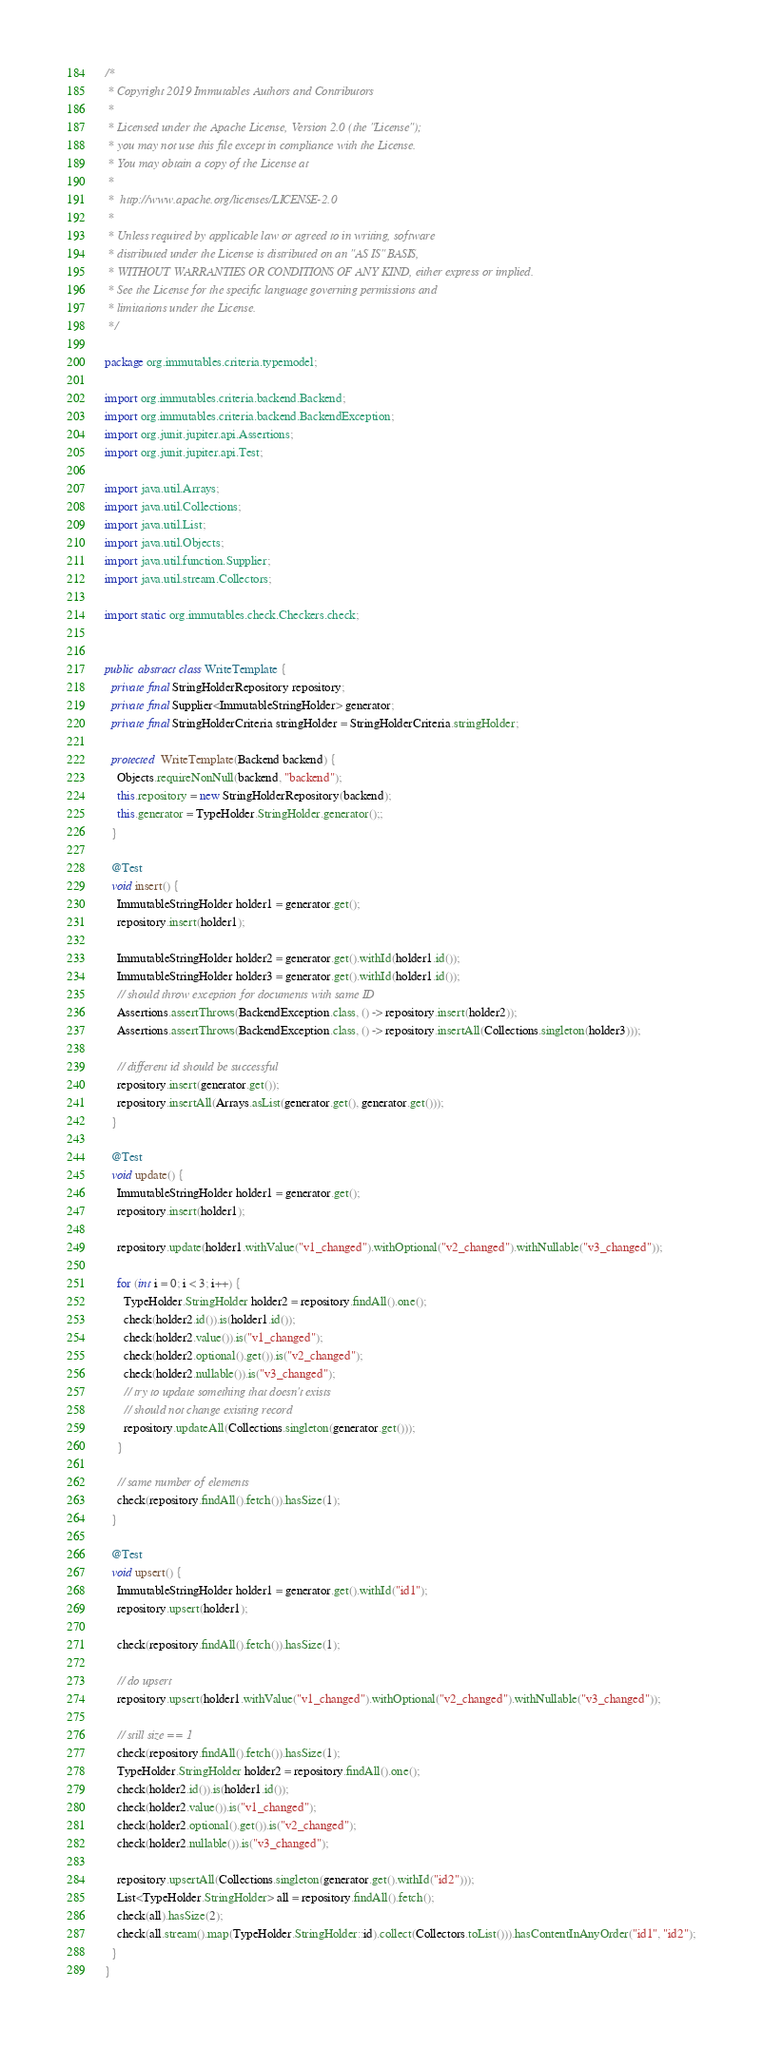Convert code to text. <code><loc_0><loc_0><loc_500><loc_500><_Java_>/*
 * Copyright 2019 Immutables Authors and Contributors
 *
 * Licensed under the Apache License, Version 2.0 (the "License");
 * you may not use this file except in compliance with the License.
 * You may obtain a copy of the License at
 *
 *  http://www.apache.org/licenses/LICENSE-2.0
 *
 * Unless required by applicable law or agreed to in writing, software
 * distributed under the License is distributed on an "AS IS" BASIS,
 * WITHOUT WARRANTIES OR CONDITIONS OF ANY KIND, either express or implied.
 * See the License for the specific language governing permissions and
 * limitations under the License.
 */

package org.immutables.criteria.typemodel;

import org.immutables.criteria.backend.Backend;
import org.immutables.criteria.backend.BackendException;
import org.junit.jupiter.api.Assertions;
import org.junit.jupiter.api.Test;

import java.util.Arrays;
import java.util.Collections;
import java.util.List;
import java.util.Objects;
import java.util.function.Supplier;
import java.util.stream.Collectors;

import static org.immutables.check.Checkers.check;


public abstract class WriteTemplate {
  private final StringHolderRepository repository;
  private final Supplier<ImmutableStringHolder> generator;
  private final StringHolderCriteria stringHolder = StringHolderCriteria.stringHolder;

  protected WriteTemplate(Backend backend) {
    Objects.requireNonNull(backend, "backend");
    this.repository = new StringHolderRepository(backend);
    this.generator = TypeHolder.StringHolder.generator();;
  }

  @Test
  void insert() {
    ImmutableStringHolder holder1 = generator.get();
    repository.insert(holder1);

    ImmutableStringHolder holder2 = generator.get().withId(holder1.id());
    ImmutableStringHolder holder3 = generator.get().withId(holder1.id());
    // should throw exception for documents with same ID
    Assertions.assertThrows(BackendException.class, () -> repository.insert(holder2));
    Assertions.assertThrows(BackendException.class, () -> repository.insertAll(Collections.singleton(holder3)));

    // different id should be successful
    repository.insert(generator.get());
    repository.insertAll(Arrays.asList(generator.get(), generator.get()));
  }

  @Test
  void update() {
    ImmutableStringHolder holder1 = generator.get();
    repository.insert(holder1);

    repository.update(holder1.withValue("v1_changed").withOptional("v2_changed").withNullable("v3_changed"));

    for (int i = 0; i < 3; i++) {
      TypeHolder.StringHolder holder2 = repository.findAll().one();
      check(holder2.id()).is(holder1.id());
      check(holder2.value()).is("v1_changed");
      check(holder2.optional().get()).is("v2_changed");
      check(holder2.nullable()).is("v3_changed");
      // try to update something that doesn't exists
      // should not change existing record
      repository.updateAll(Collections.singleton(generator.get()));
    }

    // same number of elements
    check(repository.findAll().fetch()).hasSize(1);
  }

  @Test
  void upsert() {
    ImmutableStringHolder holder1 = generator.get().withId("id1");
    repository.upsert(holder1);

    check(repository.findAll().fetch()).hasSize(1);

    // do upsert
    repository.upsert(holder1.withValue("v1_changed").withOptional("v2_changed").withNullable("v3_changed"));

    // still size == 1
    check(repository.findAll().fetch()).hasSize(1);
    TypeHolder.StringHolder holder2 = repository.findAll().one();
    check(holder2.id()).is(holder1.id());
    check(holder2.value()).is("v1_changed");
    check(holder2.optional().get()).is("v2_changed");
    check(holder2.nullable()).is("v3_changed");

    repository.upsertAll(Collections.singleton(generator.get().withId("id2")));
    List<TypeHolder.StringHolder> all = repository.findAll().fetch();
    check(all).hasSize(2);
    check(all.stream().map(TypeHolder.StringHolder::id).collect(Collectors.toList())).hasContentInAnyOrder("id1", "id2");
  }
}
</code> 